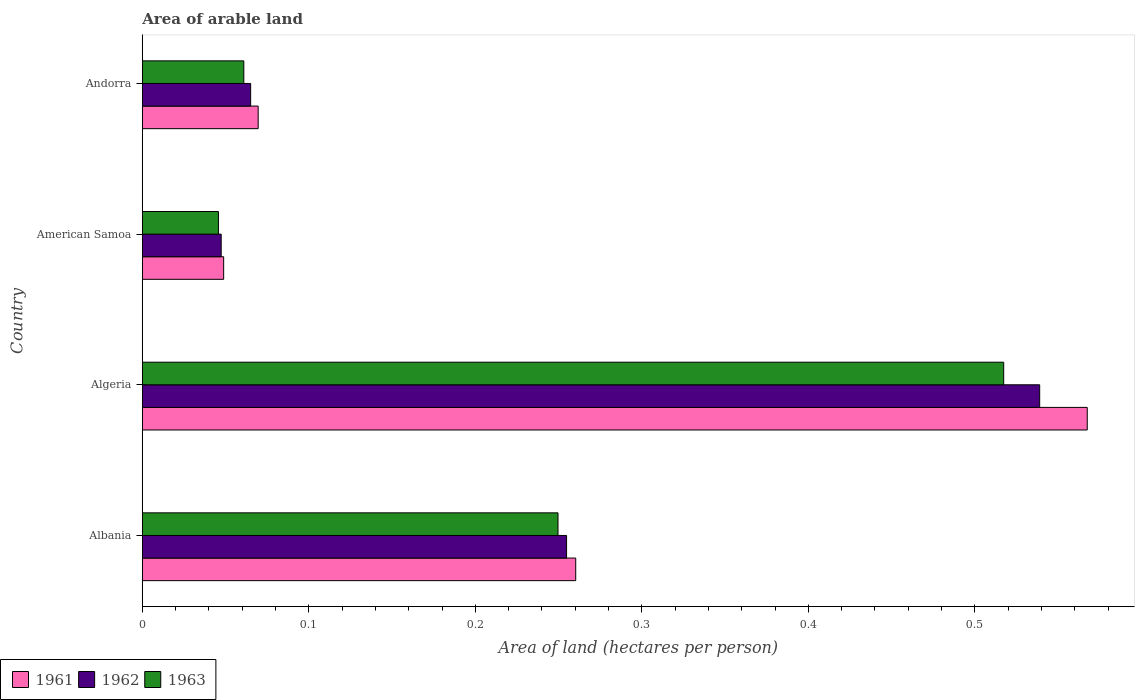How many groups of bars are there?
Provide a succinct answer. 4. How many bars are there on the 4th tick from the top?
Provide a succinct answer. 3. What is the label of the 1st group of bars from the top?
Provide a short and direct response. Andorra. What is the total arable land in 1961 in Algeria?
Provide a succinct answer. 0.57. Across all countries, what is the maximum total arable land in 1961?
Your response must be concise. 0.57. Across all countries, what is the minimum total arable land in 1963?
Your answer should be very brief. 0.05. In which country was the total arable land in 1961 maximum?
Your answer should be very brief. Algeria. In which country was the total arable land in 1963 minimum?
Your answer should be compact. American Samoa. What is the total total arable land in 1961 in the graph?
Ensure brevity in your answer.  0.95. What is the difference between the total arable land in 1961 in Albania and that in Andorra?
Your response must be concise. 0.19. What is the difference between the total arable land in 1961 in Albania and the total arable land in 1962 in American Samoa?
Offer a very short reply. 0.21. What is the average total arable land in 1961 per country?
Your response must be concise. 0.24. What is the difference between the total arable land in 1963 and total arable land in 1962 in Algeria?
Give a very brief answer. -0.02. In how many countries, is the total arable land in 1963 greater than 0.48000000000000004 hectares per person?
Ensure brevity in your answer.  1. What is the ratio of the total arable land in 1962 in Algeria to that in American Samoa?
Ensure brevity in your answer.  11.38. Is the difference between the total arable land in 1963 in Albania and American Samoa greater than the difference between the total arable land in 1962 in Albania and American Samoa?
Provide a short and direct response. No. What is the difference between the highest and the second highest total arable land in 1962?
Provide a short and direct response. 0.28. What is the difference between the highest and the lowest total arable land in 1961?
Offer a terse response. 0.52. In how many countries, is the total arable land in 1961 greater than the average total arable land in 1961 taken over all countries?
Your response must be concise. 2. What does the 3rd bar from the top in Algeria represents?
Make the answer very short. 1961. What does the 1st bar from the bottom in Andorra represents?
Keep it short and to the point. 1961. How many countries are there in the graph?
Make the answer very short. 4. What is the difference between two consecutive major ticks on the X-axis?
Offer a terse response. 0.1. Are the values on the major ticks of X-axis written in scientific E-notation?
Ensure brevity in your answer.  No. What is the title of the graph?
Keep it short and to the point. Area of arable land. What is the label or title of the X-axis?
Your answer should be compact. Area of land (hectares per person). What is the Area of land (hectares per person) in 1961 in Albania?
Make the answer very short. 0.26. What is the Area of land (hectares per person) in 1962 in Albania?
Make the answer very short. 0.25. What is the Area of land (hectares per person) of 1963 in Albania?
Give a very brief answer. 0.25. What is the Area of land (hectares per person) of 1961 in Algeria?
Your response must be concise. 0.57. What is the Area of land (hectares per person) in 1962 in Algeria?
Your response must be concise. 0.54. What is the Area of land (hectares per person) in 1963 in Algeria?
Offer a very short reply. 0.52. What is the Area of land (hectares per person) in 1961 in American Samoa?
Your answer should be very brief. 0.05. What is the Area of land (hectares per person) of 1962 in American Samoa?
Your response must be concise. 0.05. What is the Area of land (hectares per person) in 1963 in American Samoa?
Provide a short and direct response. 0.05. What is the Area of land (hectares per person) in 1961 in Andorra?
Provide a short and direct response. 0.07. What is the Area of land (hectares per person) of 1962 in Andorra?
Offer a terse response. 0.07. What is the Area of land (hectares per person) in 1963 in Andorra?
Give a very brief answer. 0.06. Across all countries, what is the maximum Area of land (hectares per person) of 1961?
Your answer should be compact. 0.57. Across all countries, what is the maximum Area of land (hectares per person) in 1962?
Your answer should be very brief. 0.54. Across all countries, what is the maximum Area of land (hectares per person) of 1963?
Your answer should be compact. 0.52. Across all countries, what is the minimum Area of land (hectares per person) of 1961?
Your answer should be compact. 0.05. Across all countries, what is the minimum Area of land (hectares per person) in 1962?
Your answer should be very brief. 0.05. Across all countries, what is the minimum Area of land (hectares per person) of 1963?
Your answer should be compact. 0.05. What is the total Area of land (hectares per person) in 1961 in the graph?
Your answer should be very brief. 0.95. What is the total Area of land (hectares per person) of 1962 in the graph?
Your answer should be compact. 0.91. What is the total Area of land (hectares per person) of 1963 in the graph?
Ensure brevity in your answer.  0.87. What is the difference between the Area of land (hectares per person) in 1961 in Albania and that in Algeria?
Keep it short and to the point. -0.31. What is the difference between the Area of land (hectares per person) in 1962 in Albania and that in Algeria?
Your answer should be compact. -0.28. What is the difference between the Area of land (hectares per person) of 1963 in Albania and that in Algeria?
Give a very brief answer. -0.27. What is the difference between the Area of land (hectares per person) in 1961 in Albania and that in American Samoa?
Offer a very short reply. 0.21. What is the difference between the Area of land (hectares per person) of 1962 in Albania and that in American Samoa?
Ensure brevity in your answer.  0.21. What is the difference between the Area of land (hectares per person) in 1963 in Albania and that in American Samoa?
Offer a terse response. 0.2. What is the difference between the Area of land (hectares per person) in 1961 in Albania and that in Andorra?
Your answer should be very brief. 0.19. What is the difference between the Area of land (hectares per person) of 1962 in Albania and that in Andorra?
Keep it short and to the point. 0.19. What is the difference between the Area of land (hectares per person) in 1963 in Albania and that in Andorra?
Ensure brevity in your answer.  0.19. What is the difference between the Area of land (hectares per person) of 1961 in Algeria and that in American Samoa?
Ensure brevity in your answer.  0.52. What is the difference between the Area of land (hectares per person) in 1962 in Algeria and that in American Samoa?
Offer a very short reply. 0.49. What is the difference between the Area of land (hectares per person) in 1963 in Algeria and that in American Samoa?
Keep it short and to the point. 0.47. What is the difference between the Area of land (hectares per person) of 1961 in Algeria and that in Andorra?
Provide a succinct answer. 0.5. What is the difference between the Area of land (hectares per person) in 1962 in Algeria and that in Andorra?
Provide a succinct answer. 0.47. What is the difference between the Area of land (hectares per person) of 1963 in Algeria and that in Andorra?
Give a very brief answer. 0.46. What is the difference between the Area of land (hectares per person) of 1961 in American Samoa and that in Andorra?
Offer a terse response. -0.02. What is the difference between the Area of land (hectares per person) of 1962 in American Samoa and that in Andorra?
Your answer should be very brief. -0.02. What is the difference between the Area of land (hectares per person) in 1963 in American Samoa and that in Andorra?
Keep it short and to the point. -0.02. What is the difference between the Area of land (hectares per person) of 1961 in Albania and the Area of land (hectares per person) of 1962 in Algeria?
Your response must be concise. -0.28. What is the difference between the Area of land (hectares per person) of 1961 in Albania and the Area of land (hectares per person) of 1963 in Algeria?
Keep it short and to the point. -0.26. What is the difference between the Area of land (hectares per person) in 1962 in Albania and the Area of land (hectares per person) in 1963 in Algeria?
Make the answer very short. -0.26. What is the difference between the Area of land (hectares per person) in 1961 in Albania and the Area of land (hectares per person) in 1962 in American Samoa?
Your answer should be compact. 0.21. What is the difference between the Area of land (hectares per person) in 1961 in Albania and the Area of land (hectares per person) in 1963 in American Samoa?
Offer a terse response. 0.21. What is the difference between the Area of land (hectares per person) in 1962 in Albania and the Area of land (hectares per person) in 1963 in American Samoa?
Offer a terse response. 0.21. What is the difference between the Area of land (hectares per person) in 1961 in Albania and the Area of land (hectares per person) in 1962 in Andorra?
Keep it short and to the point. 0.2. What is the difference between the Area of land (hectares per person) in 1961 in Albania and the Area of land (hectares per person) in 1963 in Andorra?
Keep it short and to the point. 0.2. What is the difference between the Area of land (hectares per person) of 1962 in Albania and the Area of land (hectares per person) of 1963 in Andorra?
Make the answer very short. 0.19. What is the difference between the Area of land (hectares per person) of 1961 in Algeria and the Area of land (hectares per person) of 1962 in American Samoa?
Your response must be concise. 0.52. What is the difference between the Area of land (hectares per person) in 1961 in Algeria and the Area of land (hectares per person) in 1963 in American Samoa?
Keep it short and to the point. 0.52. What is the difference between the Area of land (hectares per person) of 1962 in Algeria and the Area of land (hectares per person) of 1963 in American Samoa?
Give a very brief answer. 0.49. What is the difference between the Area of land (hectares per person) in 1961 in Algeria and the Area of land (hectares per person) in 1962 in Andorra?
Give a very brief answer. 0.5. What is the difference between the Area of land (hectares per person) of 1961 in Algeria and the Area of land (hectares per person) of 1963 in Andorra?
Give a very brief answer. 0.51. What is the difference between the Area of land (hectares per person) of 1962 in Algeria and the Area of land (hectares per person) of 1963 in Andorra?
Your answer should be compact. 0.48. What is the difference between the Area of land (hectares per person) in 1961 in American Samoa and the Area of land (hectares per person) in 1962 in Andorra?
Your response must be concise. -0.02. What is the difference between the Area of land (hectares per person) in 1961 in American Samoa and the Area of land (hectares per person) in 1963 in Andorra?
Your response must be concise. -0.01. What is the difference between the Area of land (hectares per person) of 1962 in American Samoa and the Area of land (hectares per person) of 1963 in Andorra?
Offer a very short reply. -0.01. What is the average Area of land (hectares per person) of 1961 per country?
Offer a terse response. 0.24. What is the average Area of land (hectares per person) of 1962 per country?
Your answer should be compact. 0.23. What is the average Area of land (hectares per person) of 1963 per country?
Your answer should be very brief. 0.22. What is the difference between the Area of land (hectares per person) of 1961 and Area of land (hectares per person) of 1962 in Albania?
Your answer should be compact. 0.01. What is the difference between the Area of land (hectares per person) of 1961 and Area of land (hectares per person) of 1963 in Albania?
Keep it short and to the point. 0.01. What is the difference between the Area of land (hectares per person) in 1962 and Area of land (hectares per person) in 1963 in Albania?
Provide a succinct answer. 0.01. What is the difference between the Area of land (hectares per person) in 1961 and Area of land (hectares per person) in 1962 in Algeria?
Your response must be concise. 0.03. What is the difference between the Area of land (hectares per person) of 1961 and Area of land (hectares per person) of 1963 in Algeria?
Your answer should be very brief. 0.05. What is the difference between the Area of land (hectares per person) in 1962 and Area of land (hectares per person) in 1963 in Algeria?
Ensure brevity in your answer.  0.02. What is the difference between the Area of land (hectares per person) of 1961 and Area of land (hectares per person) of 1962 in American Samoa?
Your answer should be compact. 0. What is the difference between the Area of land (hectares per person) in 1961 and Area of land (hectares per person) in 1963 in American Samoa?
Your response must be concise. 0. What is the difference between the Area of land (hectares per person) of 1962 and Area of land (hectares per person) of 1963 in American Samoa?
Your answer should be very brief. 0. What is the difference between the Area of land (hectares per person) of 1961 and Area of land (hectares per person) of 1962 in Andorra?
Provide a short and direct response. 0. What is the difference between the Area of land (hectares per person) of 1961 and Area of land (hectares per person) of 1963 in Andorra?
Provide a succinct answer. 0.01. What is the difference between the Area of land (hectares per person) of 1962 and Area of land (hectares per person) of 1963 in Andorra?
Offer a very short reply. 0. What is the ratio of the Area of land (hectares per person) in 1961 in Albania to that in Algeria?
Offer a terse response. 0.46. What is the ratio of the Area of land (hectares per person) in 1962 in Albania to that in Algeria?
Provide a short and direct response. 0.47. What is the ratio of the Area of land (hectares per person) of 1963 in Albania to that in Algeria?
Provide a succinct answer. 0.48. What is the ratio of the Area of land (hectares per person) of 1961 in Albania to that in American Samoa?
Offer a very short reply. 5.33. What is the ratio of the Area of land (hectares per person) of 1962 in Albania to that in American Samoa?
Provide a succinct answer. 5.38. What is the ratio of the Area of land (hectares per person) of 1963 in Albania to that in American Samoa?
Keep it short and to the point. 5.46. What is the ratio of the Area of land (hectares per person) in 1961 in Albania to that in Andorra?
Ensure brevity in your answer.  3.74. What is the ratio of the Area of land (hectares per person) of 1962 in Albania to that in Andorra?
Give a very brief answer. 3.92. What is the ratio of the Area of land (hectares per person) of 1963 in Albania to that in Andorra?
Give a very brief answer. 4.1. What is the ratio of the Area of land (hectares per person) in 1961 in Algeria to that in American Samoa?
Your response must be concise. 11.62. What is the ratio of the Area of land (hectares per person) in 1962 in Algeria to that in American Samoa?
Keep it short and to the point. 11.38. What is the ratio of the Area of land (hectares per person) of 1963 in Algeria to that in American Samoa?
Your answer should be very brief. 11.32. What is the ratio of the Area of land (hectares per person) in 1961 in Algeria to that in Andorra?
Ensure brevity in your answer.  8.16. What is the ratio of the Area of land (hectares per person) of 1962 in Algeria to that in Andorra?
Make the answer very short. 8.29. What is the ratio of the Area of land (hectares per person) of 1963 in Algeria to that in Andorra?
Your answer should be compact. 8.49. What is the ratio of the Area of land (hectares per person) in 1961 in American Samoa to that in Andorra?
Offer a terse response. 0.7. What is the ratio of the Area of land (hectares per person) of 1962 in American Samoa to that in Andorra?
Offer a very short reply. 0.73. What is the ratio of the Area of land (hectares per person) in 1963 in American Samoa to that in Andorra?
Ensure brevity in your answer.  0.75. What is the difference between the highest and the second highest Area of land (hectares per person) in 1961?
Your answer should be very brief. 0.31. What is the difference between the highest and the second highest Area of land (hectares per person) in 1962?
Provide a succinct answer. 0.28. What is the difference between the highest and the second highest Area of land (hectares per person) of 1963?
Offer a very short reply. 0.27. What is the difference between the highest and the lowest Area of land (hectares per person) in 1961?
Give a very brief answer. 0.52. What is the difference between the highest and the lowest Area of land (hectares per person) of 1962?
Your answer should be compact. 0.49. What is the difference between the highest and the lowest Area of land (hectares per person) in 1963?
Provide a short and direct response. 0.47. 